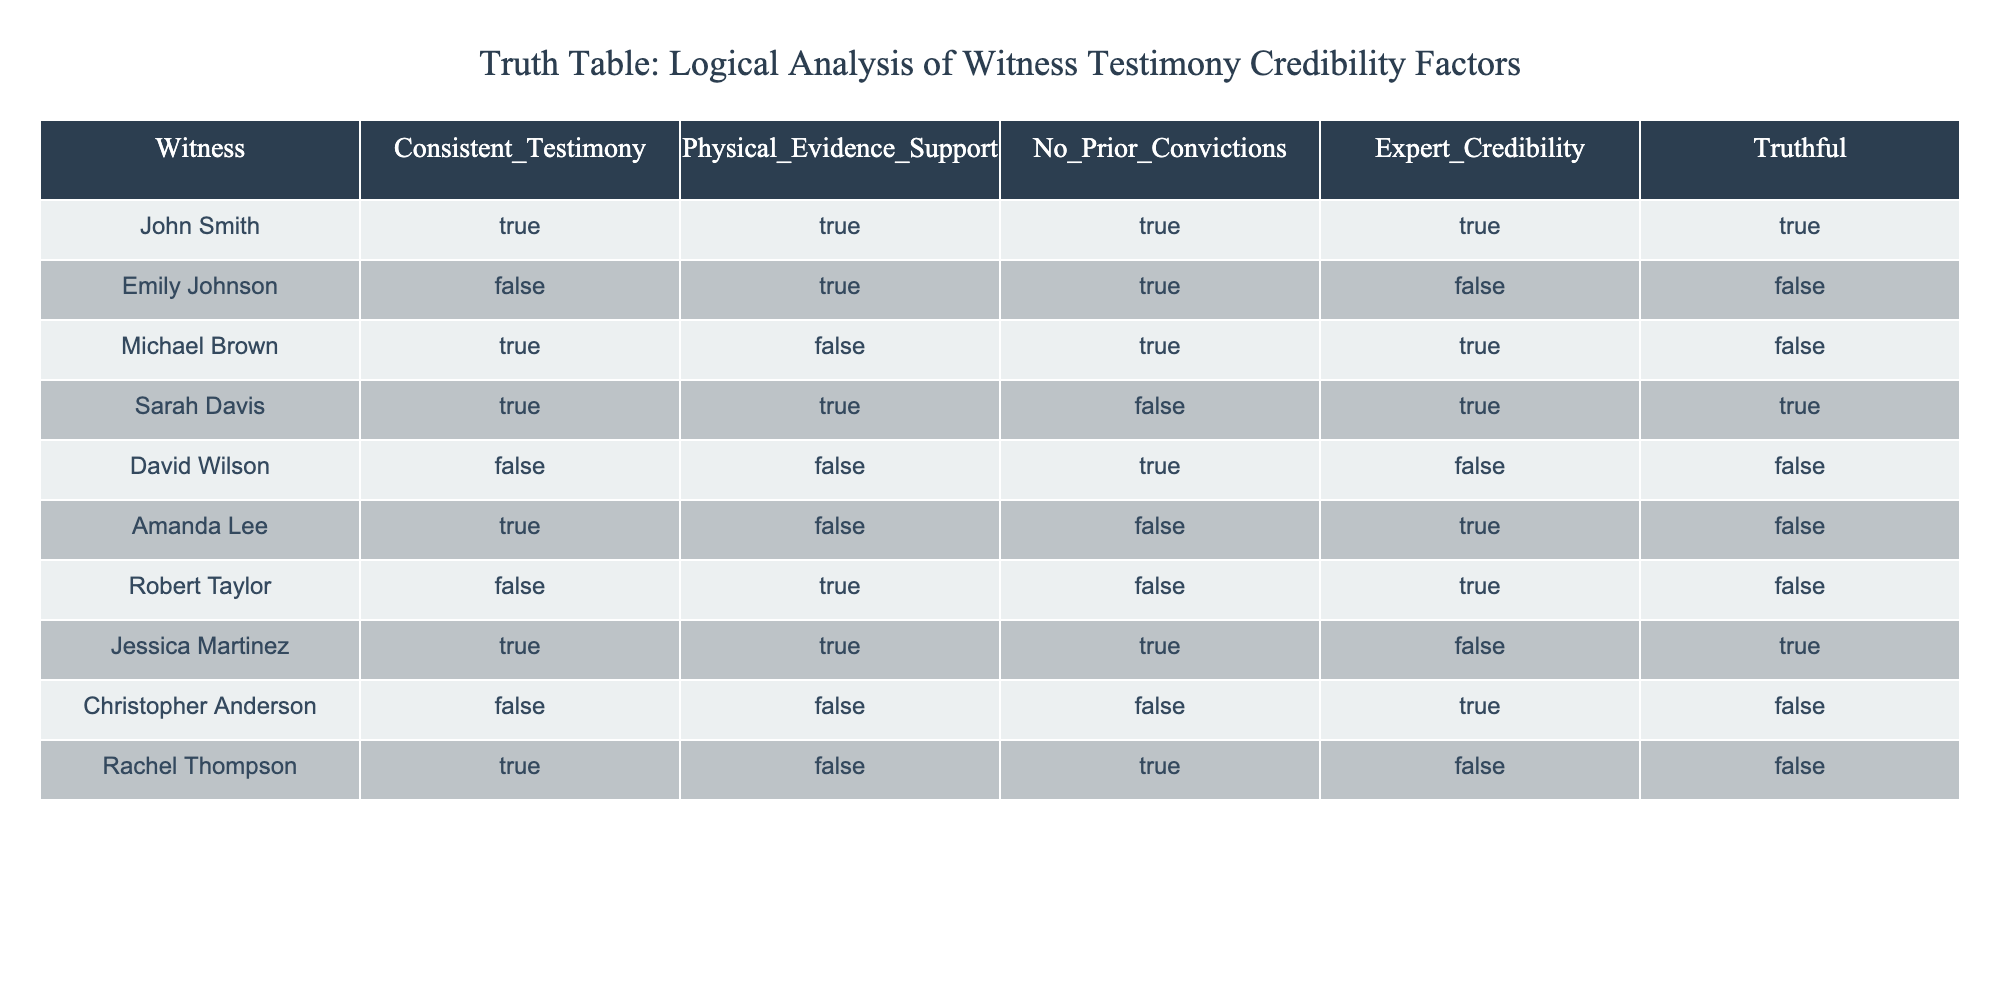What is the name of the witness with consistent testimony and no prior convictions? To answer this, we need to identify the rows where "Consistent_Testimony" is TRUE and "No_Prior_Convictions" is also TRUE. Looking at the table, John Smith and Sarah Davis meet these criteria. Thus, the answer includes both names.
Answer: John Smith, Sarah Davis How many witnesses have expert credibility and truthful testimony? In the table, we filter for rows where "Expert_Credibility" is TRUE and "Truthful" is also TRUE. By going through the data, only John Smith and Sarah Davis have both expert credibility and are truthful. We count these instances and find there are two witnesses.
Answer: 2 Is there any witness with consistent testimony, no prior convictions, and truthful? We need to look for any witnesses where "Consistent_Testimony" is TRUE, "No_Prior_Convictions" is TRUE, and "Truthful" is also TRUE. By checking each relevant row, we find that John Smith fits all these criteria.
Answer: Yes Which witness has both physical evidence support and is not truthful? We will look for rows where "Physical_Evidence_Support" is TRUE and "Truthful" is FALSE. Reviewing the data, we find that Robert Taylor has both conditions.
Answer: Robert Taylor What is the total number of witnesses who have no prior convictions but are not truthful? To find this, we filter the rows for "No_Prior_Convictions" as TRUE and "Truthful" as FALSE. Looking through the table, these witnesses are Emily Johnson, David Wilson, and Amanda Lee, resulting in a total count of three.
Answer: 3 Which witness is both expert credibility and inconsistent testimony? We look for witnesses where "Expert_Credibility" is TRUE and "Consistent_Testimony" is FALSE. In the table, only Emily Johnson and Christopher Anderson match these criteria.
Answer: Emily Johnson, Christopher Anderson How many witnesses show consistent testimony but lack both physical evidence support and expert credibility? First, we look for "Consistent_Testimony" as TRUE. Then we verify if "Physical_Evidence_Support" is FALSE and "Expert_Credibility" is FALSE. The only witness that matches the criteria is Rachel Thompson, leading to a total of one witness.
Answer: 1 What is the count of truthful witnesses who do not have physical evidence support? Here, we filter the table for rows where "Truthful" is TRUE and "Physical_Evidence_Support" is FALSE. From reviewing the table, we see Sarah Davis is one and Michael Brown is another, leading to a count of two witnesses.
Answer: 2 